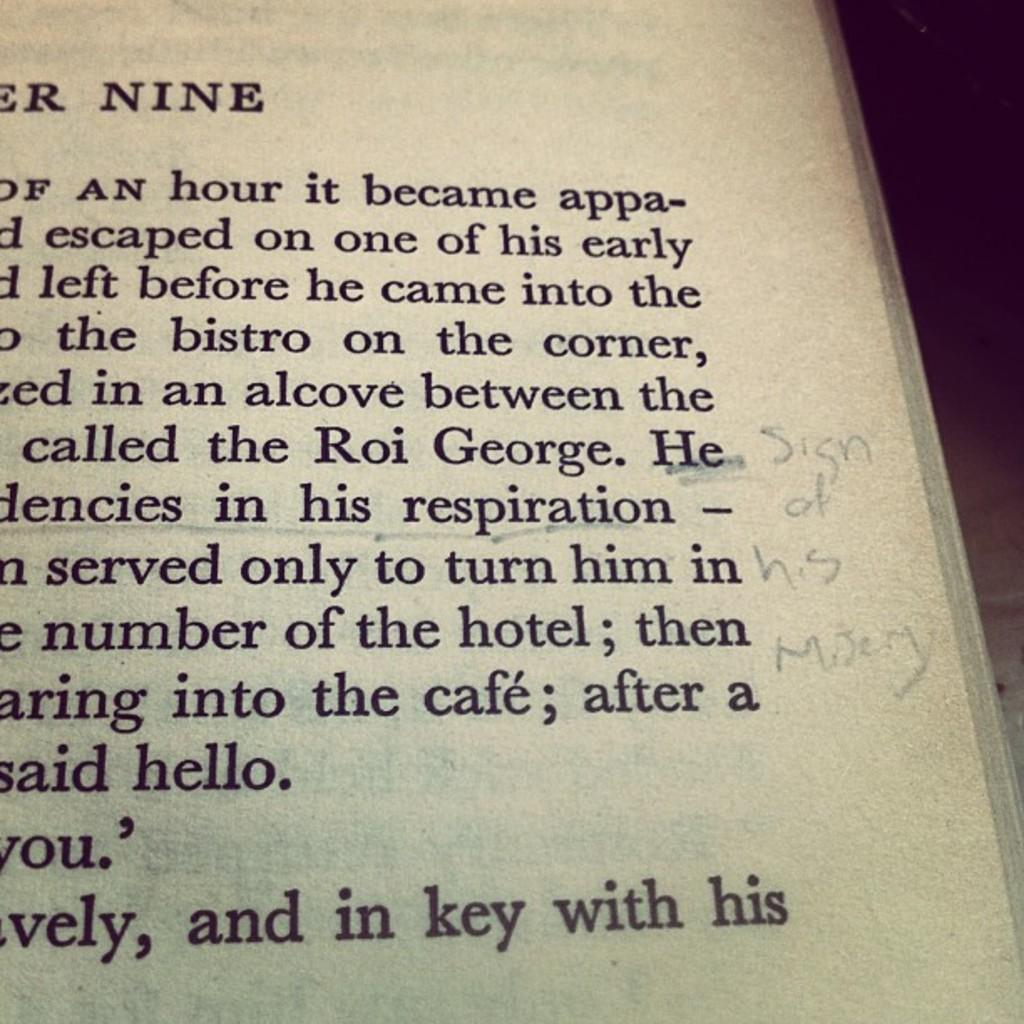<image>
Provide a brief description of the given image. The word nine is at the top of a printed page. 